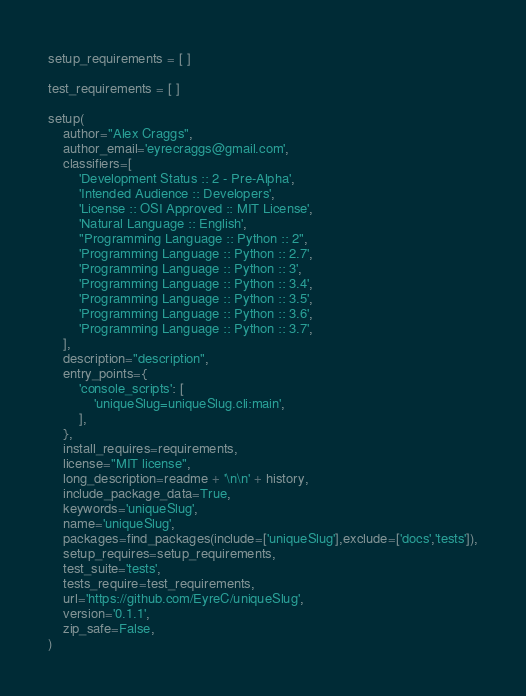Convert code to text. <code><loc_0><loc_0><loc_500><loc_500><_Python_>
setup_requirements = [ ]

test_requirements = [ ]

setup(
    author="Alex Craggs",
    author_email='eyrecraggs@gmail.com',
    classifiers=[
        'Development Status :: 2 - Pre-Alpha',
        'Intended Audience :: Developers',
        'License :: OSI Approved :: MIT License',
        'Natural Language :: English',
        "Programming Language :: Python :: 2",
        'Programming Language :: Python :: 2.7',
        'Programming Language :: Python :: 3',
        'Programming Language :: Python :: 3.4',
        'Programming Language :: Python :: 3.5',
        'Programming Language :: Python :: 3.6',
        'Programming Language :: Python :: 3.7',
    ],
    description="description",
    entry_points={
        'console_scripts': [
            'uniqueSlug=uniqueSlug.cli:main',
        ],
    },
    install_requires=requirements,
    license="MIT license",
    long_description=readme + '\n\n' + history,
    include_package_data=True,
    keywords='uniqueSlug',
    name='uniqueSlug',
    packages=find_packages(include=['uniqueSlug'],exclude=['docs','tests']),
    setup_requires=setup_requirements,
    test_suite='tests',
    tests_require=test_requirements,
    url='https://github.com/EyreC/uniqueSlug',
    version='0.1.1',
    zip_safe=False,
)
</code> 